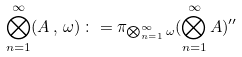Convert formula to latex. <formula><loc_0><loc_0><loc_500><loc_500>\bigotimes _ { n = 1 } ^ { \infty } ( A \, , \, \omega ) \, \colon = \pi _ { \bigotimes _ { n = 1 } ^ { \infty } \omega } ( \bigotimes _ { n = 1 } ^ { \infty } A ) ^ { \prime \prime }</formula> 